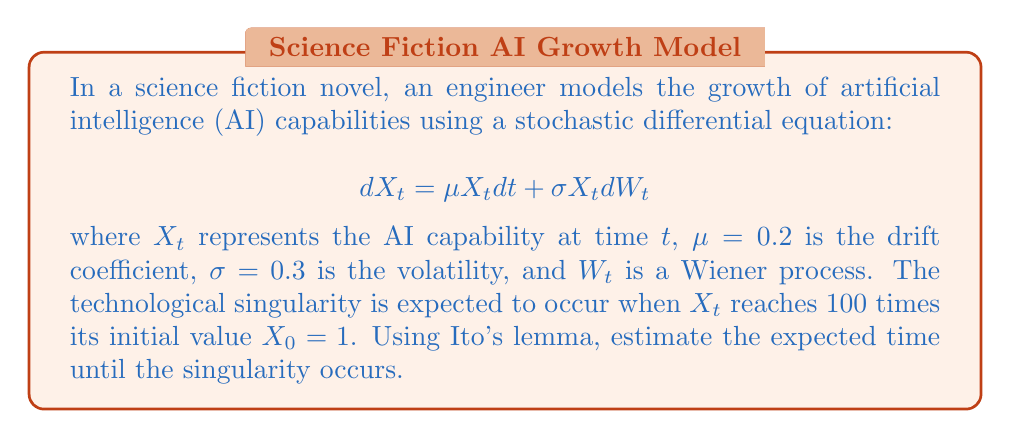Solve this math problem. To solve this problem, we'll follow these steps:

1) First, we need to apply Ito's lemma to find the solution of the stochastic differential equation. The solution is given by the geometric Brownian motion:

   $$X_t = X_0 \exp\left(\left(\mu - \frac{\sigma^2}{2}\right)t + \sigma W_t\right)$$

2) We want to find the expected time $T$ when $X_T = 100X_0$. Taking the natural logarithm of both sides:

   $$\ln(X_T) = \ln(100X_0)$$
   $$\ln(X_0) + \left(\mu - \frac{\sigma^2}{2}\right)T + \sigma W_T = \ln(100) + \ln(X_0)$$

3) Simplify:

   $$\left(\mu - \frac{\sigma^2}{2}\right)T + \sigma W_T = \ln(100)$$

4) Take the expectation of both sides. Note that $E[W_T] = 0$:

   $$\left(\mu - \frac{\sigma^2}{2}\right)E[T] = \ln(100)$$

5) Solve for $E[T]$:

   $$E[T] = \frac{\ln(100)}{\mu - \frac{\sigma^2}{2}}$$

6) Substitute the given values $\mu = 0.2$ and $\sigma = 0.3$:

   $$E[T] = \frac{\ln(100)}{0.2 - \frac{0.3^2}{2}} = \frac{4.6052}{0.1555} \approx 29.6153$$

Therefore, the expected time until the singularity occurs is approximately 29.62 years.
Answer: 29.62 years 